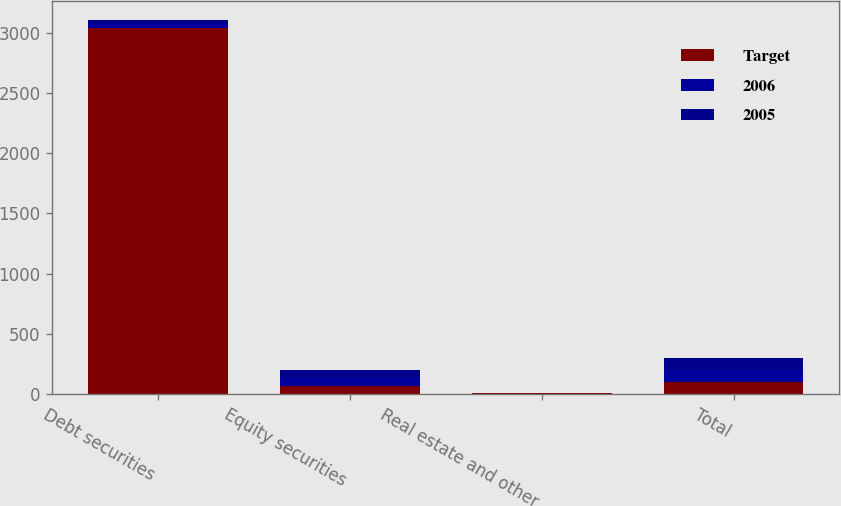Convert chart. <chart><loc_0><loc_0><loc_500><loc_500><stacked_bar_chart><ecel><fcel>Debt securities<fcel>Equity securities<fcel>Real estate and other<fcel>Total<nl><fcel>Target<fcel>3040<fcel>66<fcel>5<fcel>100<nl><fcel>2006<fcel>34<fcel>66<fcel>0<fcel>100<nl><fcel>2005<fcel>33<fcel>67<fcel>0<fcel>100<nl></chart> 